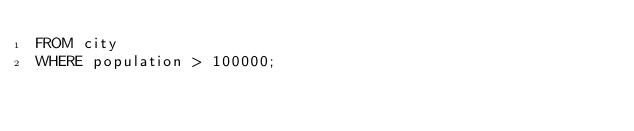<code> <loc_0><loc_0><loc_500><loc_500><_SQL_>FROM city
WHERE population > 100000;</code> 